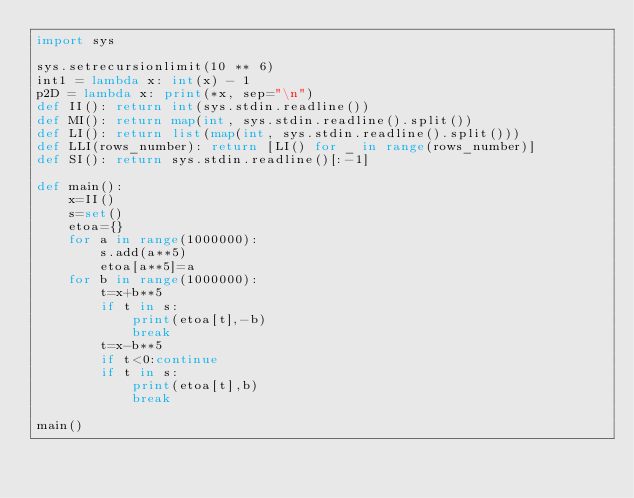Convert code to text. <code><loc_0><loc_0><loc_500><loc_500><_Python_>import sys

sys.setrecursionlimit(10 ** 6)
int1 = lambda x: int(x) - 1
p2D = lambda x: print(*x, sep="\n")
def II(): return int(sys.stdin.readline())
def MI(): return map(int, sys.stdin.readline().split())
def LI(): return list(map(int, sys.stdin.readline().split()))
def LLI(rows_number): return [LI() for _ in range(rows_number)]
def SI(): return sys.stdin.readline()[:-1]

def main():
    x=II()
    s=set()
    etoa={}
    for a in range(1000000):
        s.add(a**5)
        etoa[a**5]=a
    for b in range(1000000):
        t=x+b**5
        if t in s:
            print(etoa[t],-b)
            break
        t=x-b**5
        if t<0:continue
        if t in s:
            print(etoa[t],b)
            break

main()</code> 